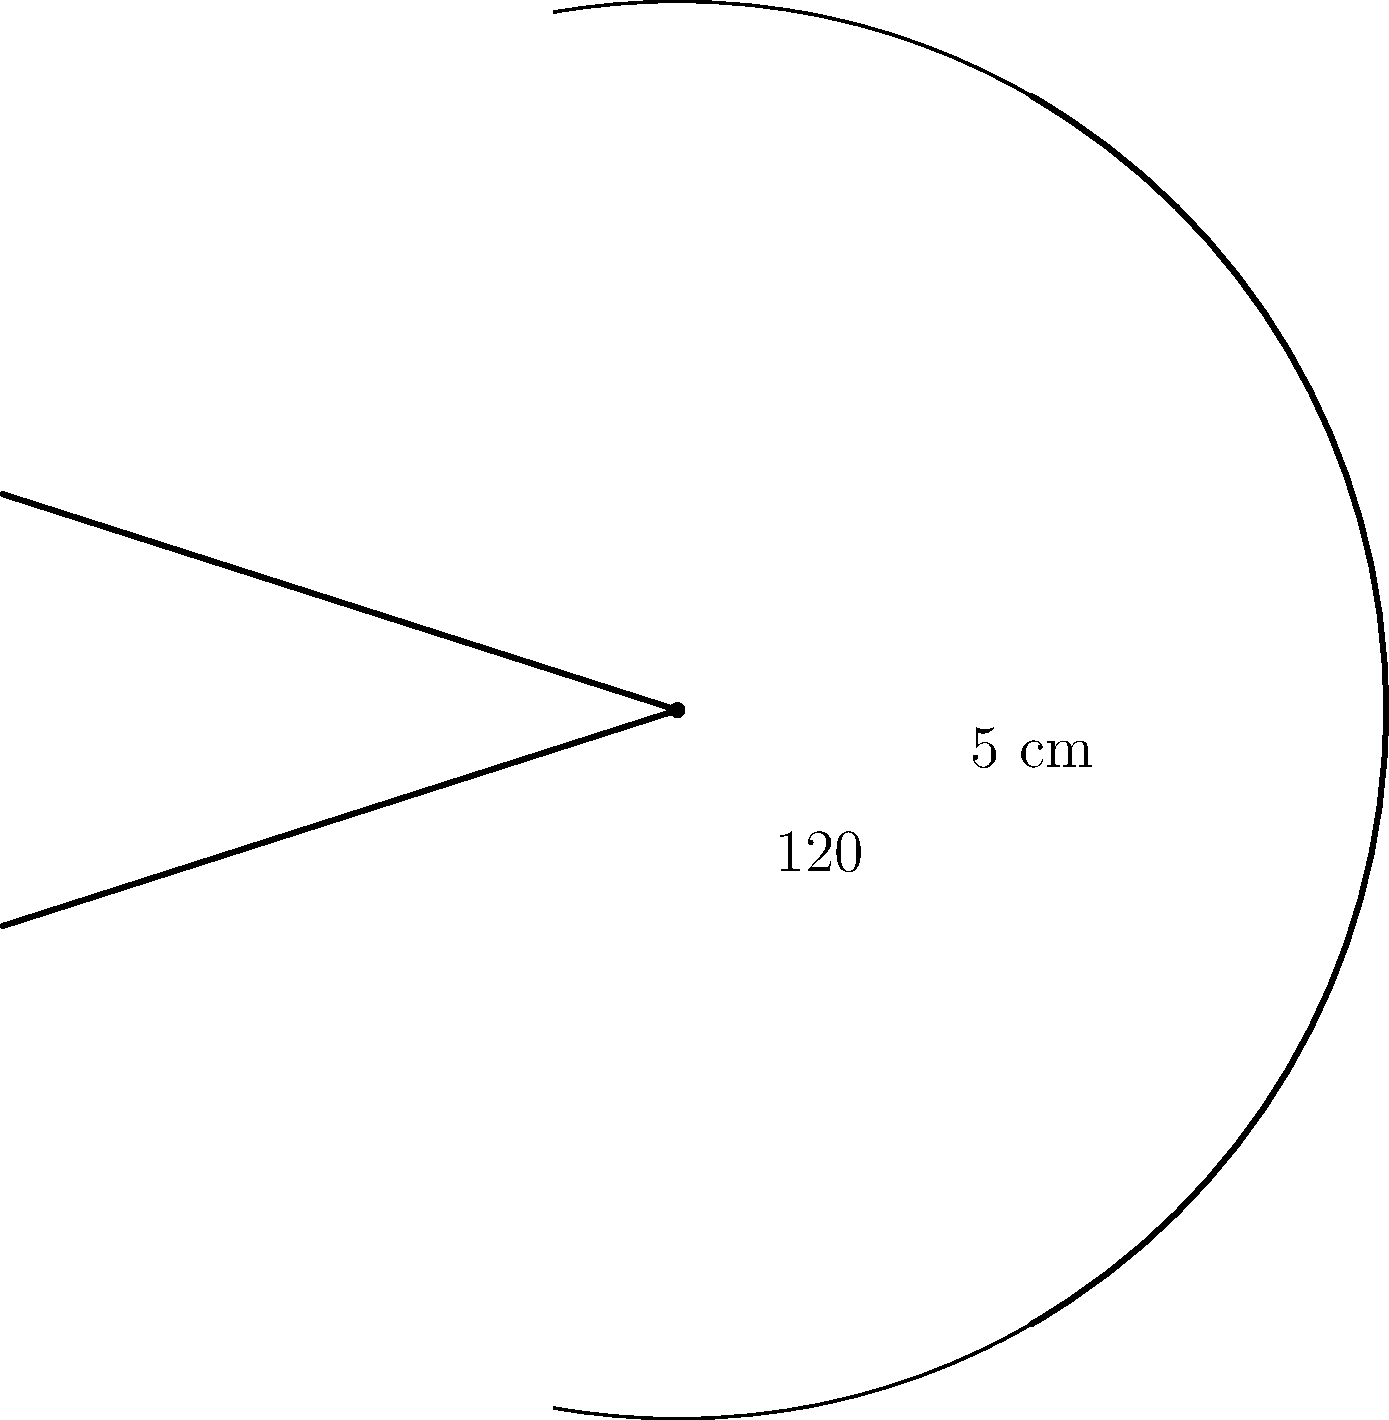As you prepare for your next performance, you notice an exquisite circular fan with intricate decorative elements. The fan forms a 120° arc with a radius of 5 cm. What is the perimeter of this ornate fan, including both the curved edge and the two straight edges? Round your answer to the nearest centimeter. To find the perimeter of the fan, we need to calculate the length of the curved edge (arc length) and add it to the lengths of the two straight edges (radii).

Step 1: Calculate the arc length
The formula for arc length is: $s = r\theta$, where $s$ is the arc length, $r$ is the radius, and $\theta$ is the central angle in radians.

First, convert 120° to radians:
$\theta = 120° \times \frac{\pi}{180°} = \frac{2\pi}{3}$ radians

Now, calculate the arc length:
$s = 5 \times \frac{2\pi}{3} = \frac{10\pi}{3}$ cm

Step 2: Calculate the length of the two straight edges
Each straight edge is a radius, so their combined length is:
$2r = 2 \times 5 = 10$ cm

Step 3: Sum up the total perimeter
Total perimeter $= \text{Arc length} + \text{Straight edges}$
$= \frac{10\pi}{3} + 10$ cm
$\approx 10.47 + 10 = 20.47$ cm

Step 4: Round to the nearest centimeter
$20.47$ cm rounds to 20 cm
Answer: 20 cm 